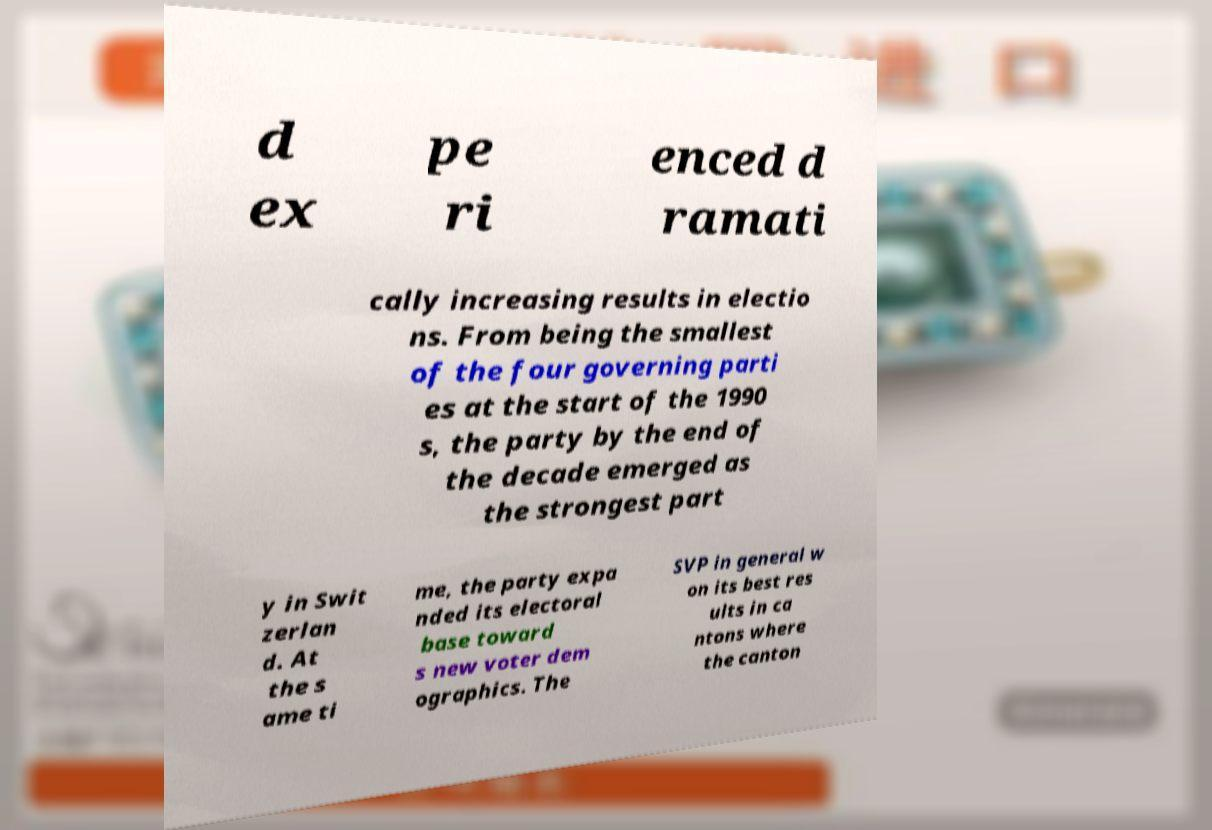There's text embedded in this image that I need extracted. Can you transcribe it verbatim? d ex pe ri enced d ramati cally increasing results in electio ns. From being the smallest of the four governing parti es at the start of the 1990 s, the party by the end of the decade emerged as the strongest part y in Swit zerlan d. At the s ame ti me, the party expa nded its electoral base toward s new voter dem ographics. The SVP in general w on its best res ults in ca ntons where the canton 